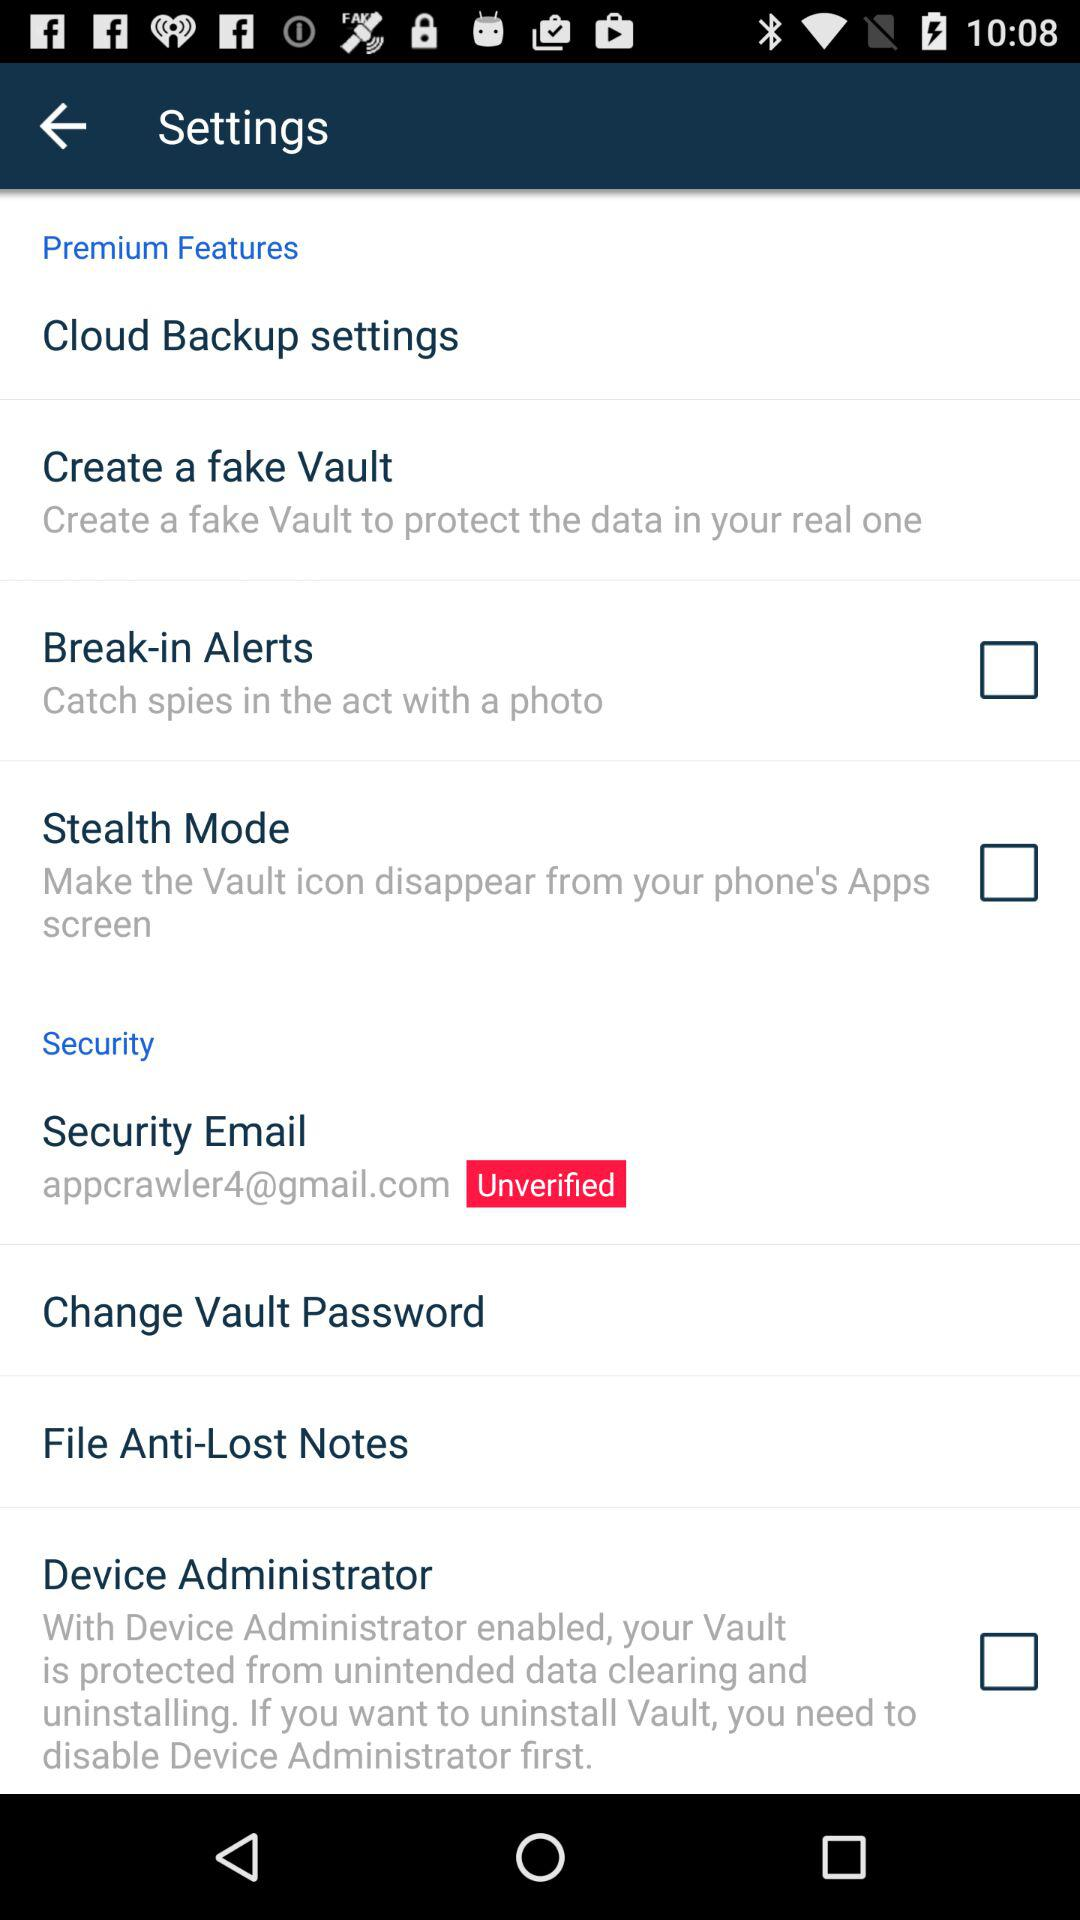What is the current status of the "Break-in Alerts"? The current status is "on". 